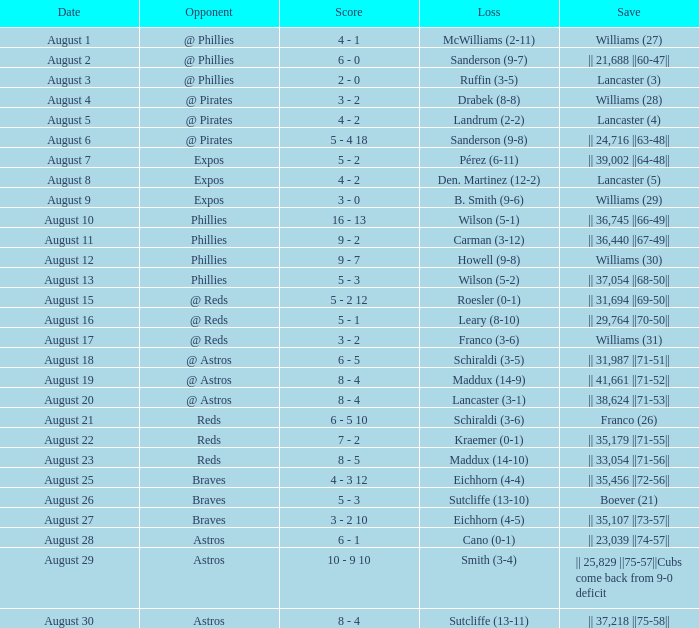Can you give me this table as a dict? {'header': ['Date', 'Opponent', 'Score', 'Loss', 'Save'], 'rows': [['August 1', '@ Phillies', '4 - 1', 'McWilliams (2-11)', 'Williams (27)'], ['August 2', '@ Phillies', '6 - 0', 'Sanderson (9-7)', '|| 21,688 ||60-47||'], ['August 3', '@ Phillies', '2 - 0', 'Ruffin (3-5)', 'Lancaster (3)'], ['August 4', '@ Pirates', '3 - 2', 'Drabek (8-8)', 'Williams (28)'], ['August 5', '@ Pirates', '4 - 2', 'Landrum (2-2)', 'Lancaster (4)'], ['August 6', '@ Pirates', '5 - 4 18', 'Sanderson (9-8)', '|| 24,716 ||63-48||'], ['August 7', 'Expos', '5 - 2', 'Pérez (6-11)', '|| 39,002 ||64-48||'], ['August 8', 'Expos', '4 - 2', 'Den. Martinez (12-2)', 'Lancaster (5)'], ['August 9', 'Expos', '3 - 0', 'B. Smith (9-6)', 'Williams (29)'], ['August 10', 'Phillies', '16 - 13', 'Wilson (5-1)', '|| 36,745 ||66-49||'], ['August 11', 'Phillies', '9 - 2', 'Carman (3-12)', '|| 36,440 ||67-49||'], ['August 12', 'Phillies', '9 - 7', 'Howell (9-8)', 'Williams (30)'], ['August 13', 'Phillies', '5 - 3', 'Wilson (5-2)', '|| 37,054 ||68-50||'], ['August 15', '@ Reds', '5 - 2 12', 'Roesler (0-1)', '|| 31,694 ||69-50||'], ['August 16', '@ Reds', '5 - 1', 'Leary (8-10)', '|| 29,764 ||70-50||'], ['August 17', '@ Reds', '3 - 2', 'Franco (3-6)', 'Williams (31)'], ['August 18', '@ Astros', '6 - 5', 'Schiraldi (3-5)', '|| 31,987 ||71-51||'], ['August 19', '@ Astros', '8 - 4', 'Maddux (14-9)', '|| 41,661 ||71-52||'], ['August 20', '@ Astros', '8 - 4', 'Lancaster (3-1)', '|| 38,624 ||71-53||'], ['August 21', 'Reds', '6 - 5 10', 'Schiraldi (3-6)', 'Franco (26)'], ['August 22', 'Reds', '7 - 2', 'Kraemer (0-1)', '|| 35,179 ||71-55||'], ['August 23', 'Reds', '8 - 5', 'Maddux (14-10)', '|| 33,054 ||71-56||'], ['August 25', 'Braves', '4 - 3 12', 'Eichhorn (4-4)', '|| 35,456 ||72-56||'], ['August 26', 'Braves', '5 - 3', 'Sutcliffe (13-10)', 'Boever (21)'], ['August 27', 'Braves', '3 - 2 10', 'Eichhorn (4-5)', '|| 35,107 ||73-57||'], ['August 28', 'Astros', '6 - 1', 'Cano (0-1)', '|| 23,039 ||74-57||'], ['August 29', 'Astros', '10 - 9 10', 'Smith (3-4)', '|| 25,829 ||75-57||Cubs come back from 9-0 deficit'], ['August 30', 'Astros', '8 - 4', 'Sutcliffe (13-11)', '|| 37,218 ||75-58||']]} Name the date for loss of ruffin (3-5) August 3. 